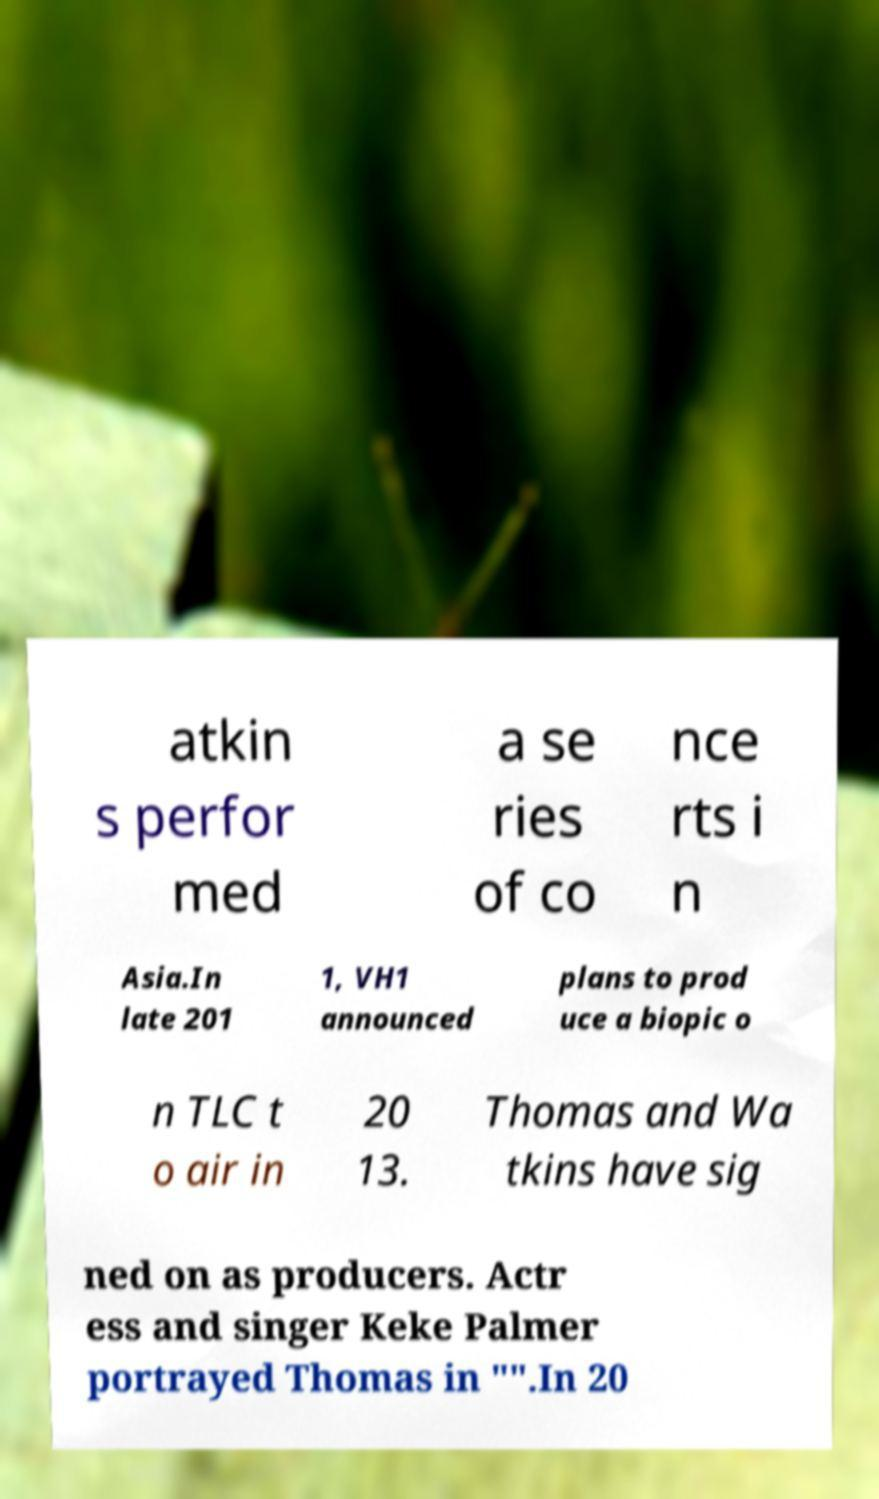Please identify and transcribe the text found in this image. atkin s perfor med a se ries of co nce rts i n Asia.In late 201 1, VH1 announced plans to prod uce a biopic o n TLC t o air in 20 13. Thomas and Wa tkins have sig ned on as producers. Actr ess and singer Keke Palmer portrayed Thomas in "".In 20 